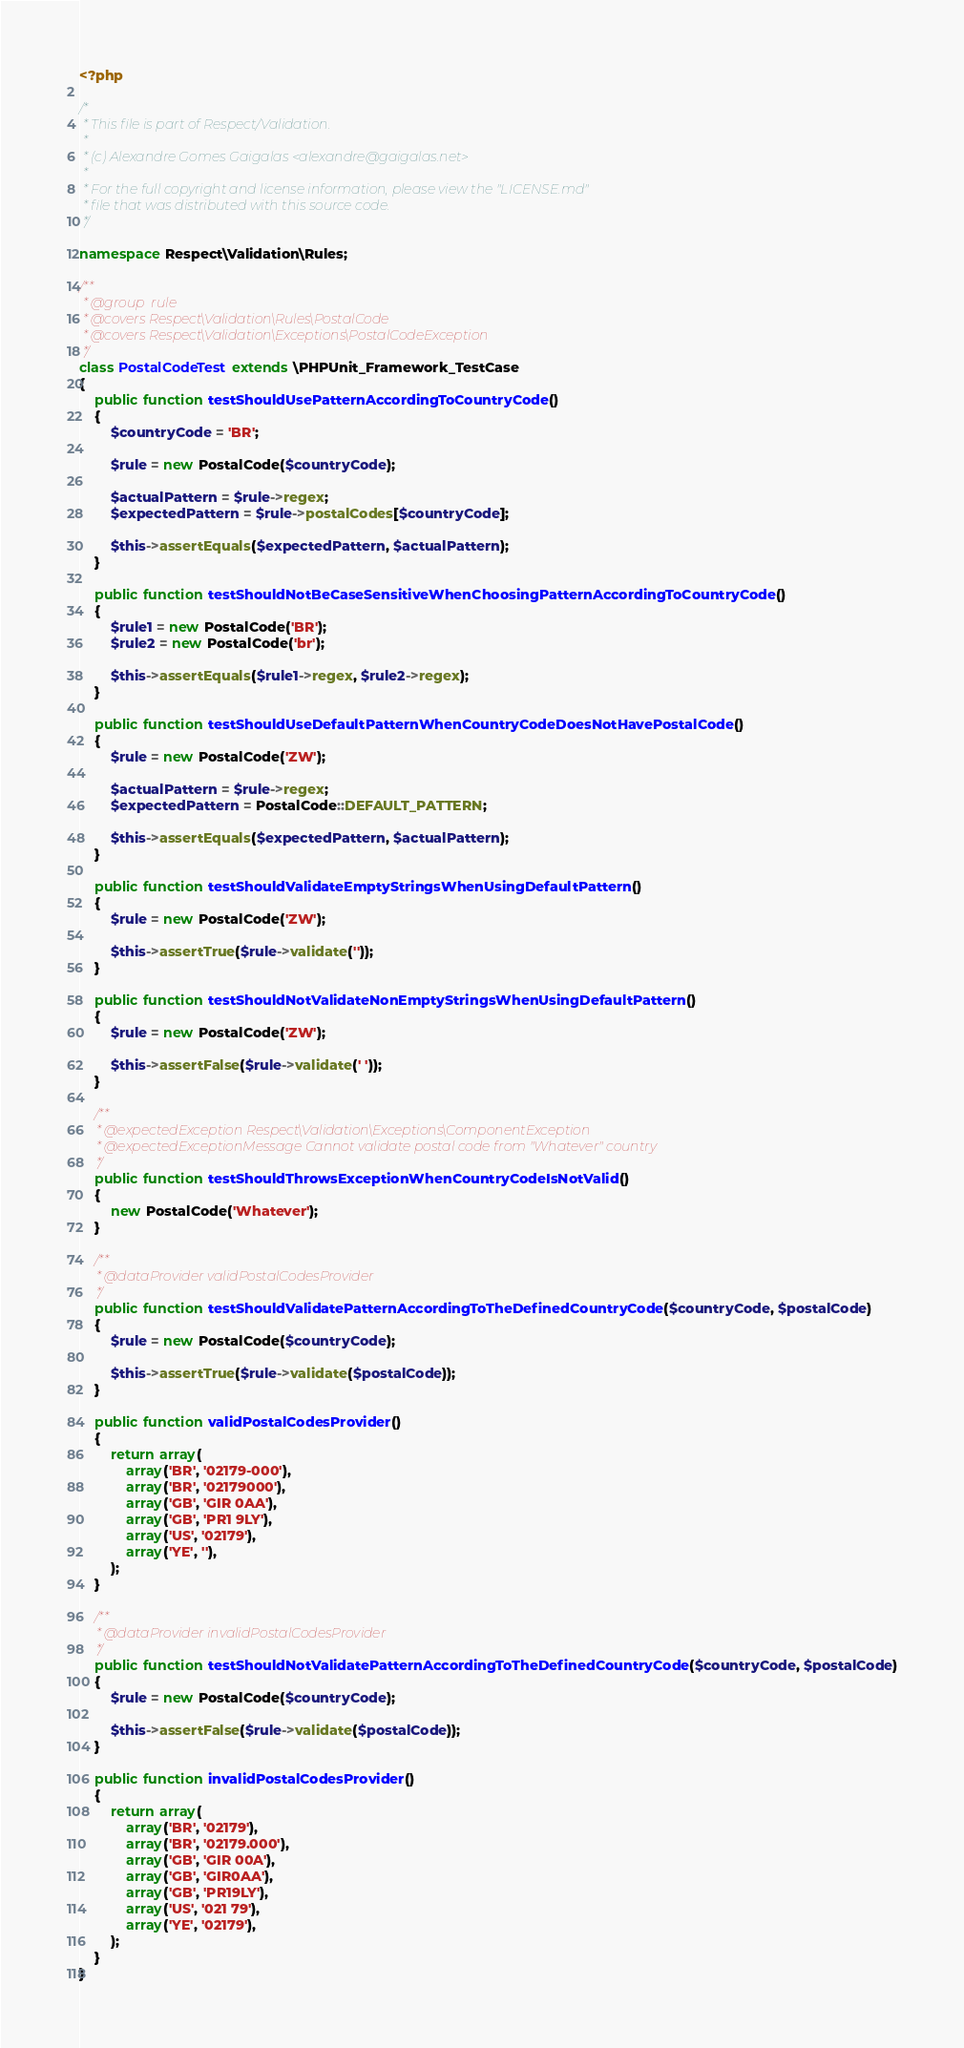<code> <loc_0><loc_0><loc_500><loc_500><_PHP_><?php

/*
 * This file is part of Respect/Validation.
 *
 * (c) Alexandre Gomes Gaigalas <alexandre@gaigalas.net>
 *
 * For the full copyright and license information, please view the "LICENSE.md"
 * file that was distributed with this source code.
 */

namespace Respect\Validation\Rules;

/**
 * @group  rule
 * @covers Respect\Validation\Rules\PostalCode
 * @covers Respect\Validation\Exceptions\PostalCodeException
 */
class PostalCodeTest extends \PHPUnit_Framework_TestCase
{
    public function testShouldUsePatternAccordingToCountryCode()
    {
        $countryCode = 'BR';

        $rule = new PostalCode($countryCode);

        $actualPattern = $rule->regex;
        $expectedPattern = $rule->postalCodes[$countryCode];

        $this->assertEquals($expectedPattern, $actualPattern);
    }

    public function testShouldNotBeCaseSensitiveWhenChoosingPatternAccordingToCountryCode()
    {
        $rule1 = new PostalCode('BR');
        $rule2 = new PostalCode('br');

        $this->assertEquals($rule1->regex, $rule2->regex);
    }

    public function testShouldUseDefaultPatternWhenCountryCodeDoesNotHavePostalCode()
    {
        $rule = new PostalCode('ZW');

        $actualPattern = $rule->regex;
        $expectedPattern = PostalCode::DEFAULT_PATTERN;

        $this->assertEquals($expectedPattern, $actualPattern);
    }

    public function testShouldValidateEmptyStringsWhenUsingDefaultPattern()
    {
        $rule = new PostalCode('ZW');

        $this->assertTrue($rule->validate(''));
    }

    public function testShouldNotValidateNonEmptyStringsWhenUsingDefaultPattern()
    {
        $rule = new PostalCode('ZW');

        $this->assertFalse($rule->validate(' '));
    }

    /**
     * @expectedException Respect\Validation\Exceptions\ComponentException
     * @expectedExceptionMessage Cannot validate postal code from "Whatever" country
     */
    public function testShouldThrowsExceptionWhenCountryCodeIsNotValid()
    {
        new PostalCode('Whatever');
    }

    /**
     * @dataProvider validPostalCodesProvider
     */
    public function testShouldValidatePatternAccordingToTheDefinedCountryCode($countryCode, $postalCode)
    {
        $rule = new PostalCode($countryCode);

        $this->assertTrue($rule->validate($postalCode));
    }

    public function validPostalCodesProvider()
    {
        return array(
            array('BR', '02179-000'),
            array('BR', '02179000'),
            array('GB', 'GIR 0AA'),
            array('GB', 'PR1 9LY'),
            array('US', '02179'),
            array('YE', ''),
        );
    }

    /**
     * @dataProvider invalidPostalCodesProvider
     */
    public function testShouldNotValidatePatternAccordingToTheDefinedCountryCode($countryCode, $postalCode)
    {
        $rule = new PostalCode($countryCode);

        $this->assertFalse($rule->validate($postalCode));
    }

    public function invalidPostalCodesProvider()
    {
        return array(
            array('BR', '02179'),
            array('BR', '02179.000'),
            array('GB', 'GIR 00A'),
            array('GB', 'GIR0AA'),
            array('GB', 'PR19LY'),
            array('US', '021 79'),
            array('YE', '02179'),
        );
    }
}
</code> 